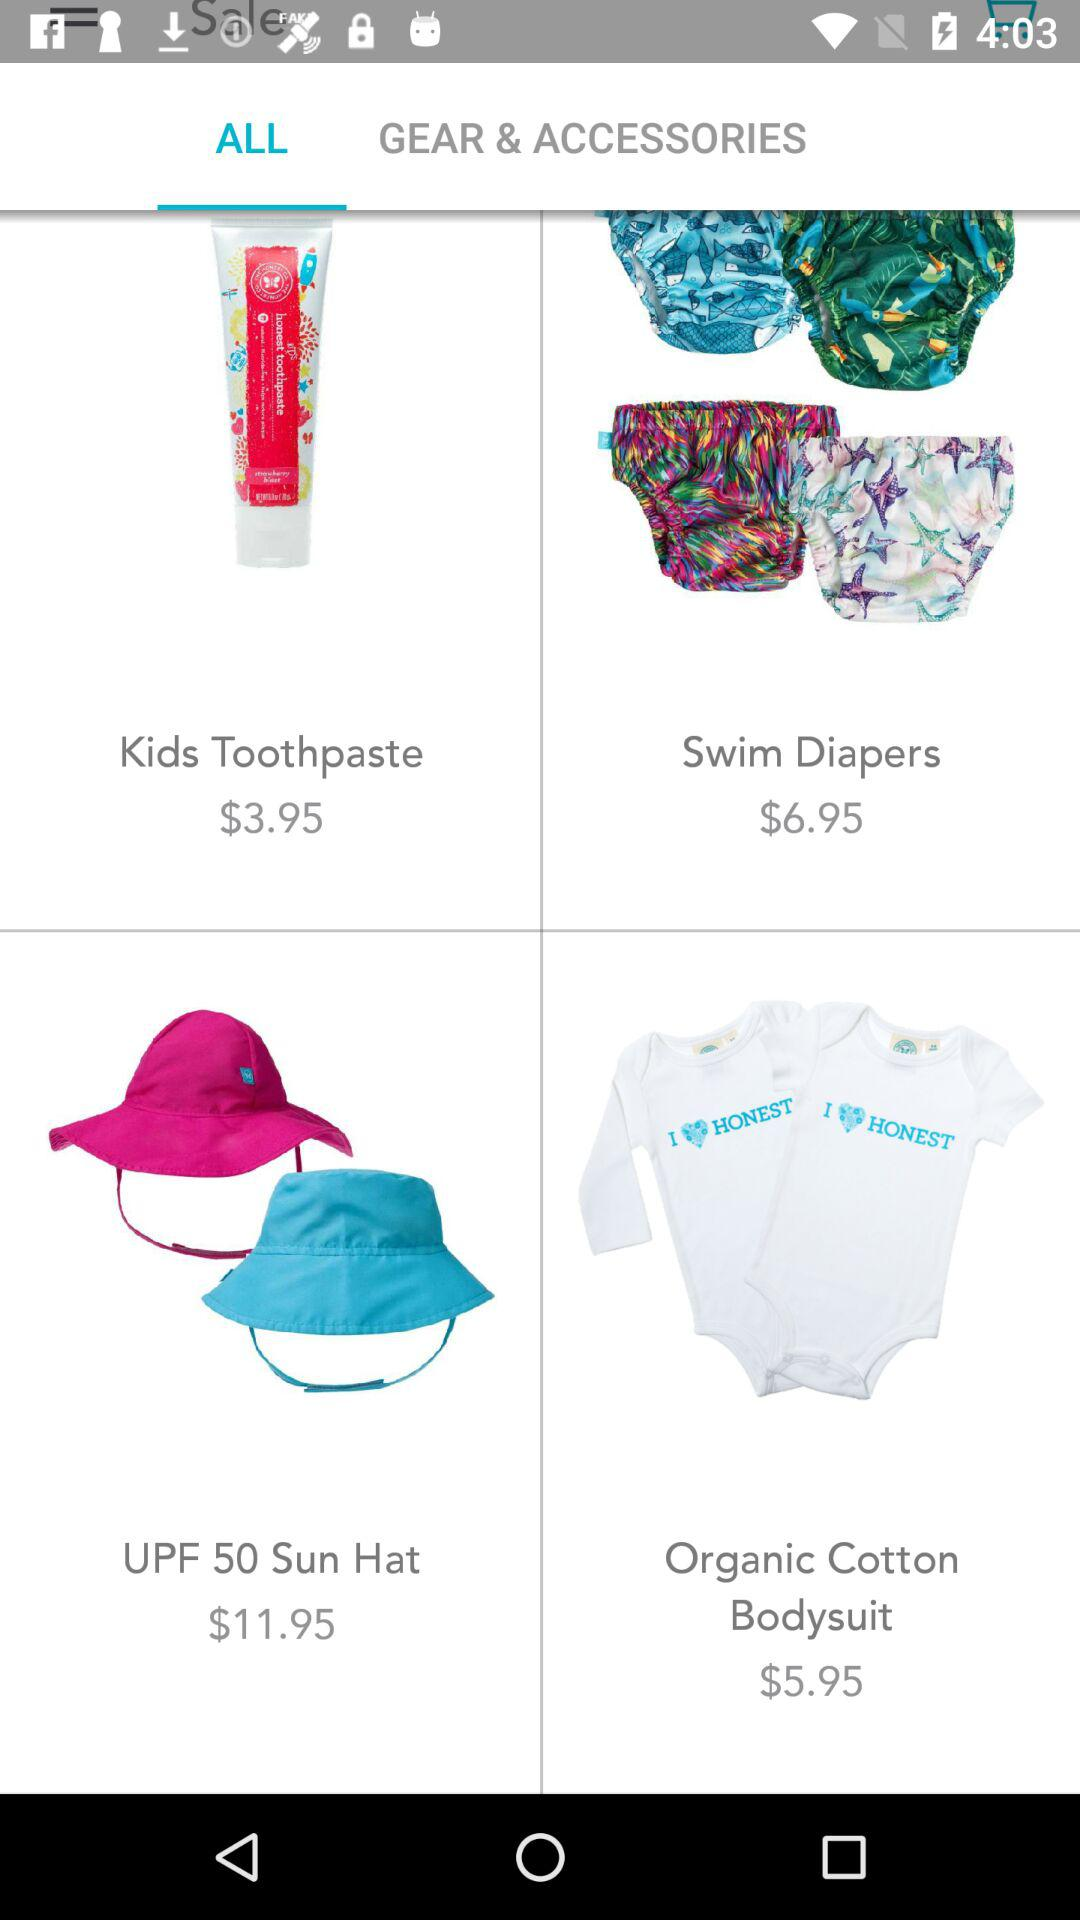What is the price of kids toothpaste? The price is $3.95. 